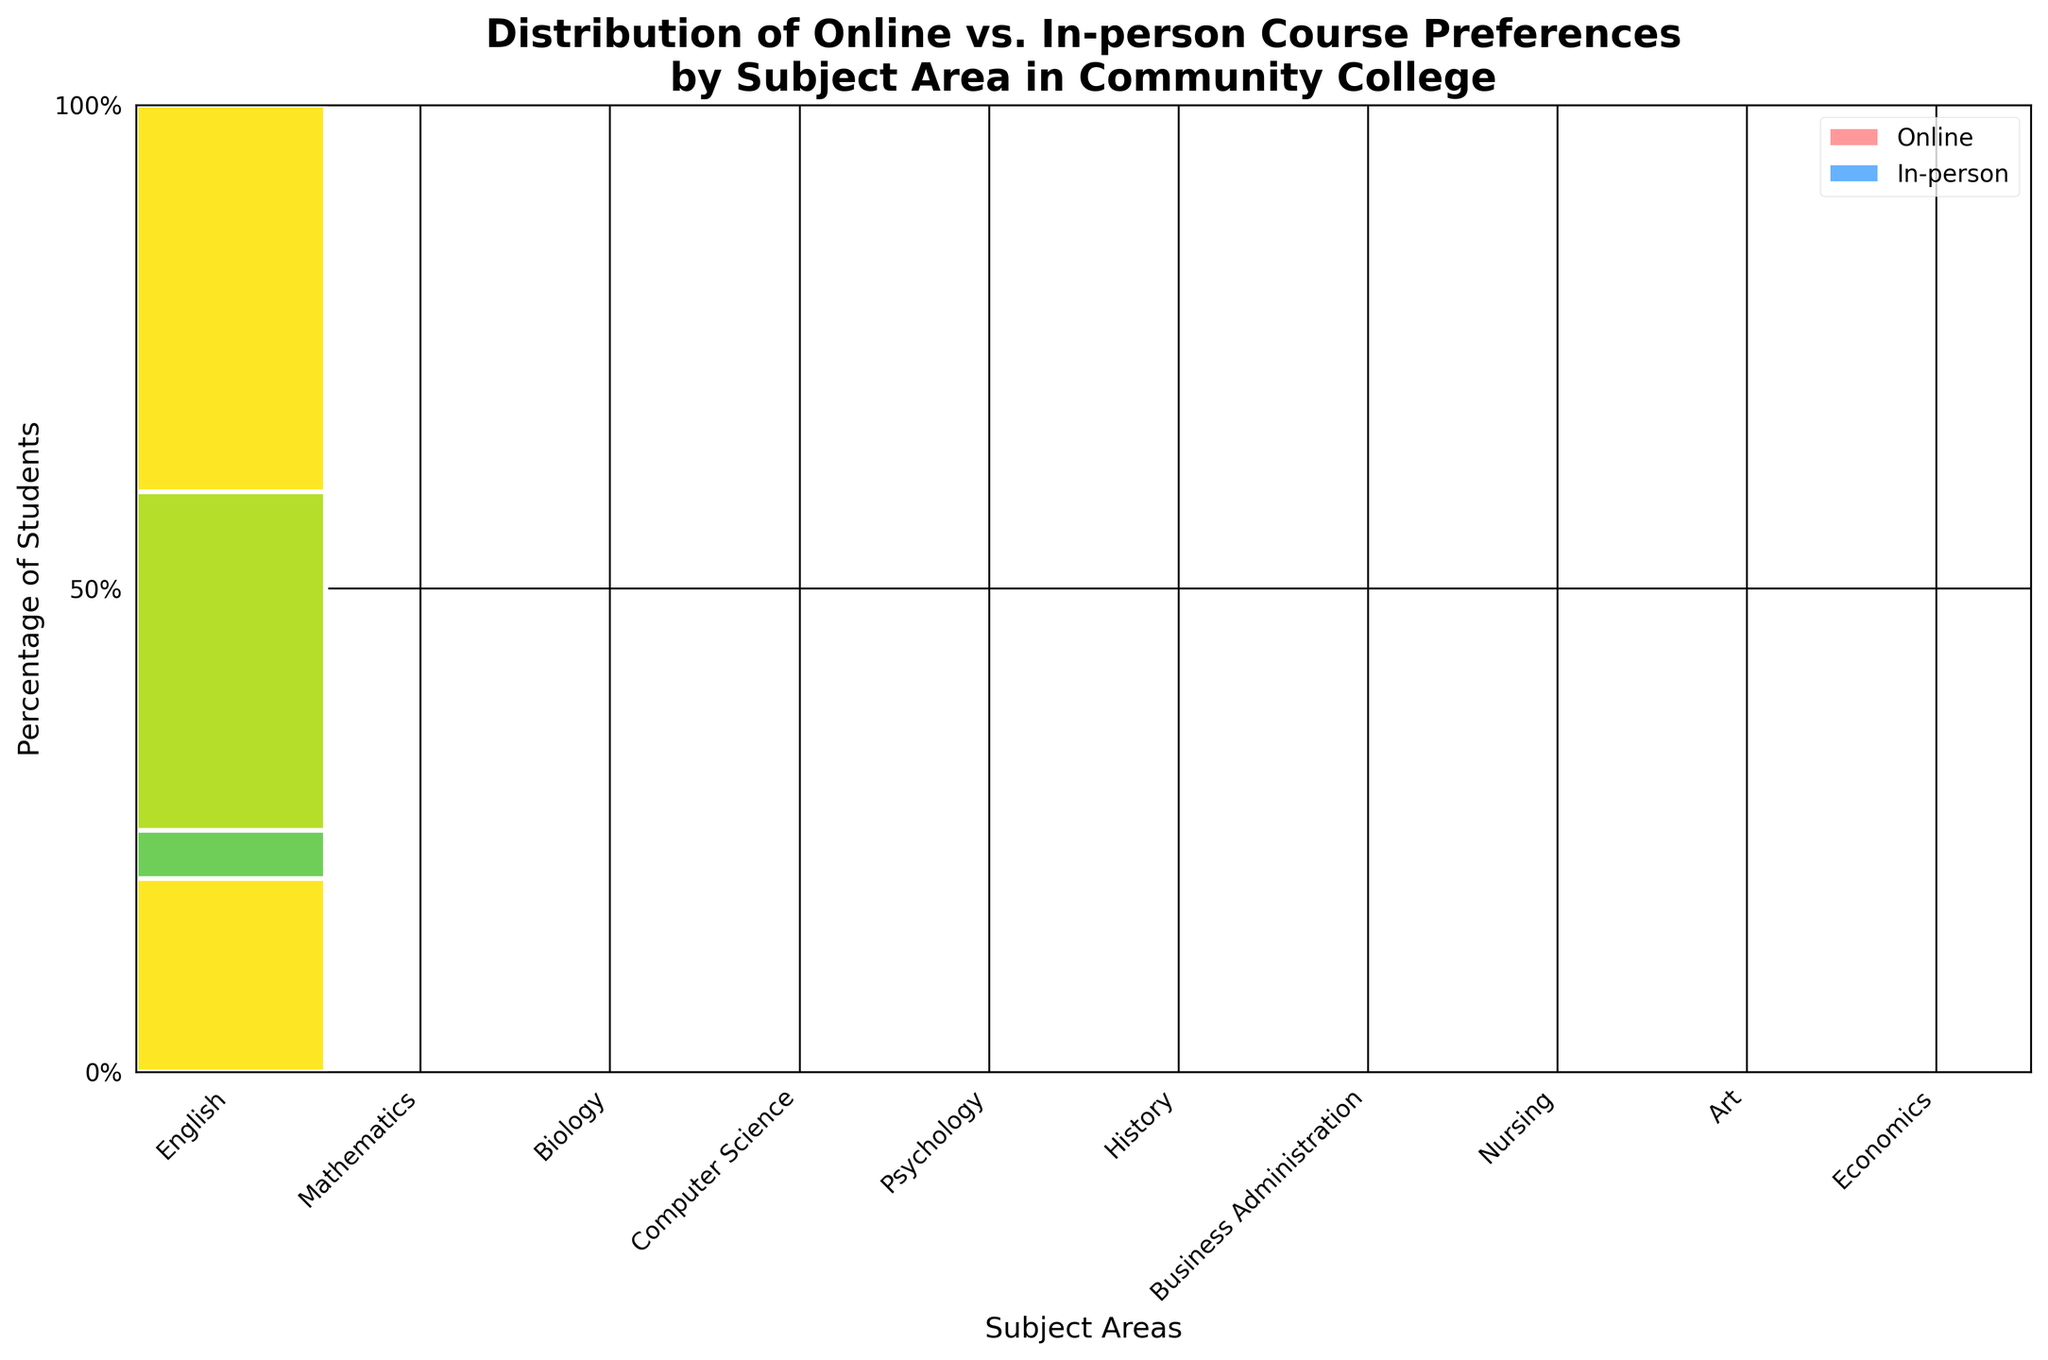Which subject has the highest percentage of students preferring online courses? Computer Science has the highest percentage of students preferring online courses at 80%. This can be observed by looking at the height of the "Online" segment for each subject.
Answer: Computer Science Which subject has the highest preference for in-person courses? Nursing has the highest preference for in-person courses at 80%. By comparing the height of the "In-person" segments in each subject's section, it is clear that Nursing reaches the 80% mark.
Answer: Nursing What is the total percentage of students preferring online courses in Business Administration and Economics combined? The online percentages for Business Administration and Economics are 70% and 60%, respectively. Adding them together, the total is 70% + 60% = 130%.
Answer: 130% How does the preference for online courses compare between Mathematics and English? Mathematics has a lower preference for online courses at 40%, whereas English has a higher preference at 65%. By comparing the heights of the "Online" segments for these subjects, it's clear that English's segment is taller.
Answer: English has higher Which subject has an equal distribution of preference for online and in-person courses? History has an equal distribution for online and in-person courses. This is evident as both "Online" and "In-person" segments are of equal height.
Answer: History What is the difference in percentage between online and in-person preferences for Art courses? The percentage for online courses in Art is 25%, and for in-person, it is 75%. The difference is 75% - 25% = 50%.
Answer: 50% If combined, what is the total number of students preferring online courses in English and Nursing? English has 65 students preferring online courses, and Nursing has 20. Adding these, the total is 65 + 20 = 85 students.
Answer: 85 Which subject area has the smallest percentage of students preferring online courses? Art has the smallest percentage of students preferring online courses at 25%. This is identified by comparing the heights of the "Online" segments across all subjects.
Answer: Art What percentage of students prefer in-person courses in Psychology? Psychology has 45% of students preferring in-person courses. This is noted by examining the height of the "In-person" segment for Psychology.
Answer: 45% Are there more students preferring online or in-person courses in Psychology? In Psychology, more students prefer online courses (55%) compared to in-person courses (45%). This can be discerned by comparing the relative heights of the segments.
Answer: Online 